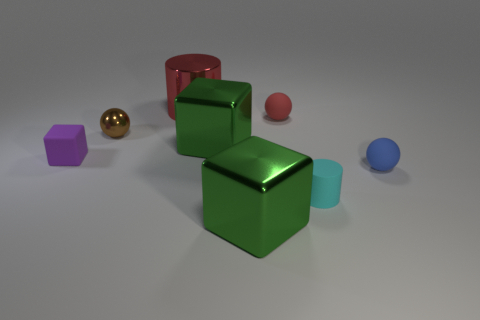Is the number of big green objects that are in front of the tiny purple object less than the number of large metal objects that are behind the red shiny cylinder?
Offer a terse response. No. What is the size of the brown metallic object that is the same shape as the blue rubber thing?
Offer a very short reply. Small. What number of things are either metallic objects that are in front of the red cylinder or matte balls that are behind the small brown sphere?
Provide a succinct answer. 4. Do the blue sphere and the purple block have the same size?
Provide a succinct answer. Yes. Is the number of large metallic cylinders greater than the number of tiny green matte balls?
Keep it short and to the point. Yes. What number of other things are the same color as the rubber block?
Offer a terse response. 0. How many things are red metallic things or tiny red spheres?
Your response must be concise. 2. Is the shape of the matte thing that is behind the tiny purple object the same as  the blue rubber thing?
Ensure brevity in your answer.  Yes. There is a small rubber object behind the cube left of the red metal thing; what color is it?
Provide a succinct answer. Red. Are there fewer red metal cylinders than green objects?
Your answer should be very brief. Yes. 